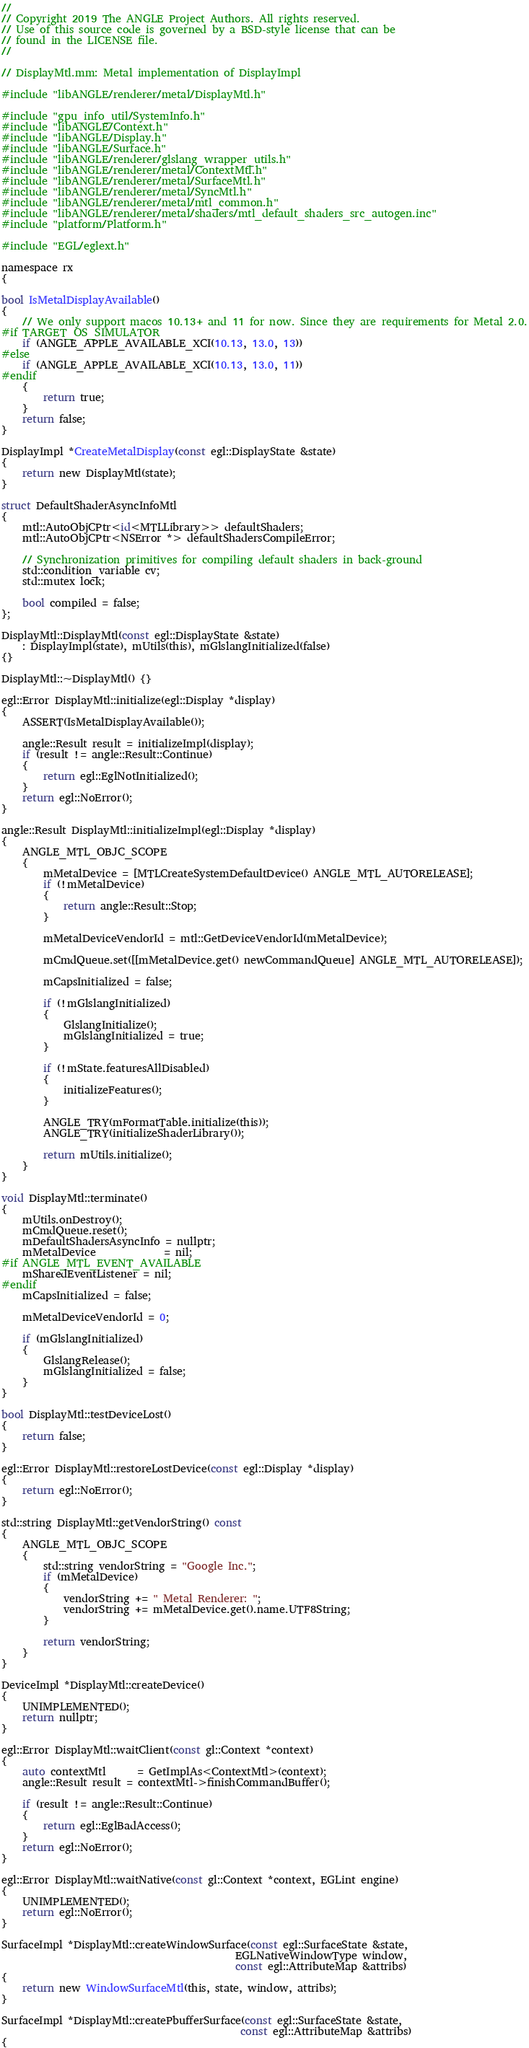Convert code to text. <code><loc_0><loc_0><loc_500><loc_500><_ObjectiveC_>//
// Copyright 2019 The ANGLE Project Authors. All rights reserved.
// Use of this source code is governed by a BSD-style license that can be
// found in the LICENSE file.
//

// DisplayMtl.mm: Metal implementation of DisplayImpl

#include "libANGLE/renderer/metal/DisplayMtl.h"

#include "gpu_info_util/SystemInfo.h"
#include "libANGLE/Context.h"
#include "libANGLE/Display.h"
#include "libANGLE/Surface.h"
#include "libANGLE/renderer/glslang_wrapper_utils.h"
#include "libANGLE/renderer/metal/ContextMtl.h"
#include "libANGLE/renderer/metal/SurfaceMtl.h"
#include "libANGLE/renderer/metal/SyncMtl.h"
#include "libANGLE/renderer/metal/mtl_common.h"
#include "libANGLE/renderer/metal/shaders/mtl_default_shaders_src_autogen.inc"
#include "platform/Platform.h"

#include "EGL/eglext.h"

namespace rx
{

bool IsMetalDisplayAvailable()
{
    // We only support macos 10.13+ and 11 for now. Since they are requirements for Metal 2.0.
#if TARGET_OS_SIMULATOR
    if (ANGLE_APPLE_AVAILABLE_XCI(10.13, 13.0, 13))
#else
    if (ANGLE_APPLE_AVAILABLE_XCI(10.13, 13.0, 11))
#endif
    {
        return true;
    }
    return false;
}

DisplayImpl *CreateMetalDisplay(const egl::DisplayState &state)
{
    return new DisplayMtl(state);
}

struct DefaultShaderAsyncInfoMtl
{
    mtl::AutoObjCPtr<id<MTLLibrary>> defaultShaders;
    mtl::AutoObjCPtr<NSError *> defaultShadersCompileError;

    // Synchronization primitives for compiling default shaders in back-ground
    std::condition_variable cv;
    std::mutex lock;

    bool compiled = false;
};

DisplayMtl::DisplayMtl(const egl::DisplayState &state)
    : DisplayImpl(state), mUtils(this), mGlslangInitialized(false)
{}

DisplayMtl::~DisplayMtl() {}

egl::Error DisplayMtl::initialize(egl::Display *display)
{
    ASSERT(IsMetalDisplayAvailable());

    angle::Result result = initializeImpl(display);
    if (result != angle::Result::Continue)
    {
        return egl::EglNotInitialized();
    }
    return egl::NoError();
}

angle::Result DisplayMtl::initializeImpl(egl::Display *display)
{
    ANGLE_MTL_OBJC_SCOPE
    {
        mMetalDevice = [MTLCreateSystemDefaultDevice() ANGLE_MTL_AUTORELEASE];
        if (!mMetalDevice)
        {
            return angle::Result::Stop;
        }

        mMetalDeviceVendorId = mtl::GetDeviceVendorId(mMetalDevice);

        mCmdQueue.set([[mMetalDevice.get() newCommandQueue] ANGLE_MTL_AUTORELEASE]);

        mCapsInitialized = false;

        if (!mGlslangInitialized)
        {
            GlslangInitialize();
            mGlslangInitialized = true;
        }

        if (!mState.featuresAllDisabled)
        {
            initializeFeatures();
        }

        ANGLE_TRY(mFormatTable.initialize(this));
        ANGLE_TRY(initializeShaderLibrary());

        return mUtils.initialize();
    }
}

void DisplayMtl::terminate()
{
    mUtils.onDestroy();
    mCmdQueue.reset();
    mDefaultShadersAsyncInfo = nullptr;
    mMetalDevice             = nil;
#if ANGLE_MTL_EVENT_AVAILABLE
    mSharedEventListener = nil;
#endif
    mCapsInitialized = false;

    mMetalDeviceVendorId = 0;

    if (mGlslangInitialized)
    {
        GlslangRelease();
        mGlslangInitialized = false;
    }
}

bool DisplayMtl::testDeviceLost()
{
    return false;
}

egl::Error DisplayMtl::restoreLostDevice(const egl::Display *display)
{
    return egl::NoError();
}

std::string DisplayMtl::getVendorString() const
{
    ANGLE_MTL_OBJC_SCOPE
    {
        std::string vendorString = "Google Inc.";
        if (mMetalDevice)
        {
            vendorString += " Metal Renderer: ";
            vendorString += mMetalDevice.get().name.UTF8String;
        }

        return vendorString;
    }
}

DeviceImpl *DisplayMtl::createDevice()
{
    UNIMPLEMENTED();
    return nullptr;
}

egl::Error DisplayMtl::waitClient(const gl::Context *context)
{
    auto contextMtl      = GetImplAs<ContextMtl>(context);
    angle::Result result = contextMtl->finishCommandBuffer();

    if (result != angle::Result::Continue)
    {
        return egl::EglBadAccess();
    }
    return egl::NoError();
}

egl::Error DisplayMtl::waitNative(const gl::Context *context, EGLint engine)
{
    UNIMPLEMENTED();
    return egl::NoError();
}

SurfaceImpl *DisplayMtl::createWindowSurface(const egl::SurfaceState &state,
                                             EGLNativeWindowType window,
                                             const egl::AttributeMap &attribs)
{
    return new WindowSurfaceMtl(this, state, window, attribs);
}

SurfaceImpl *DisplayMtl::createPbufferSurface(const egl::SurfaceState &state,
                                              const egl::AttributeMap &attribs)
{</code> 